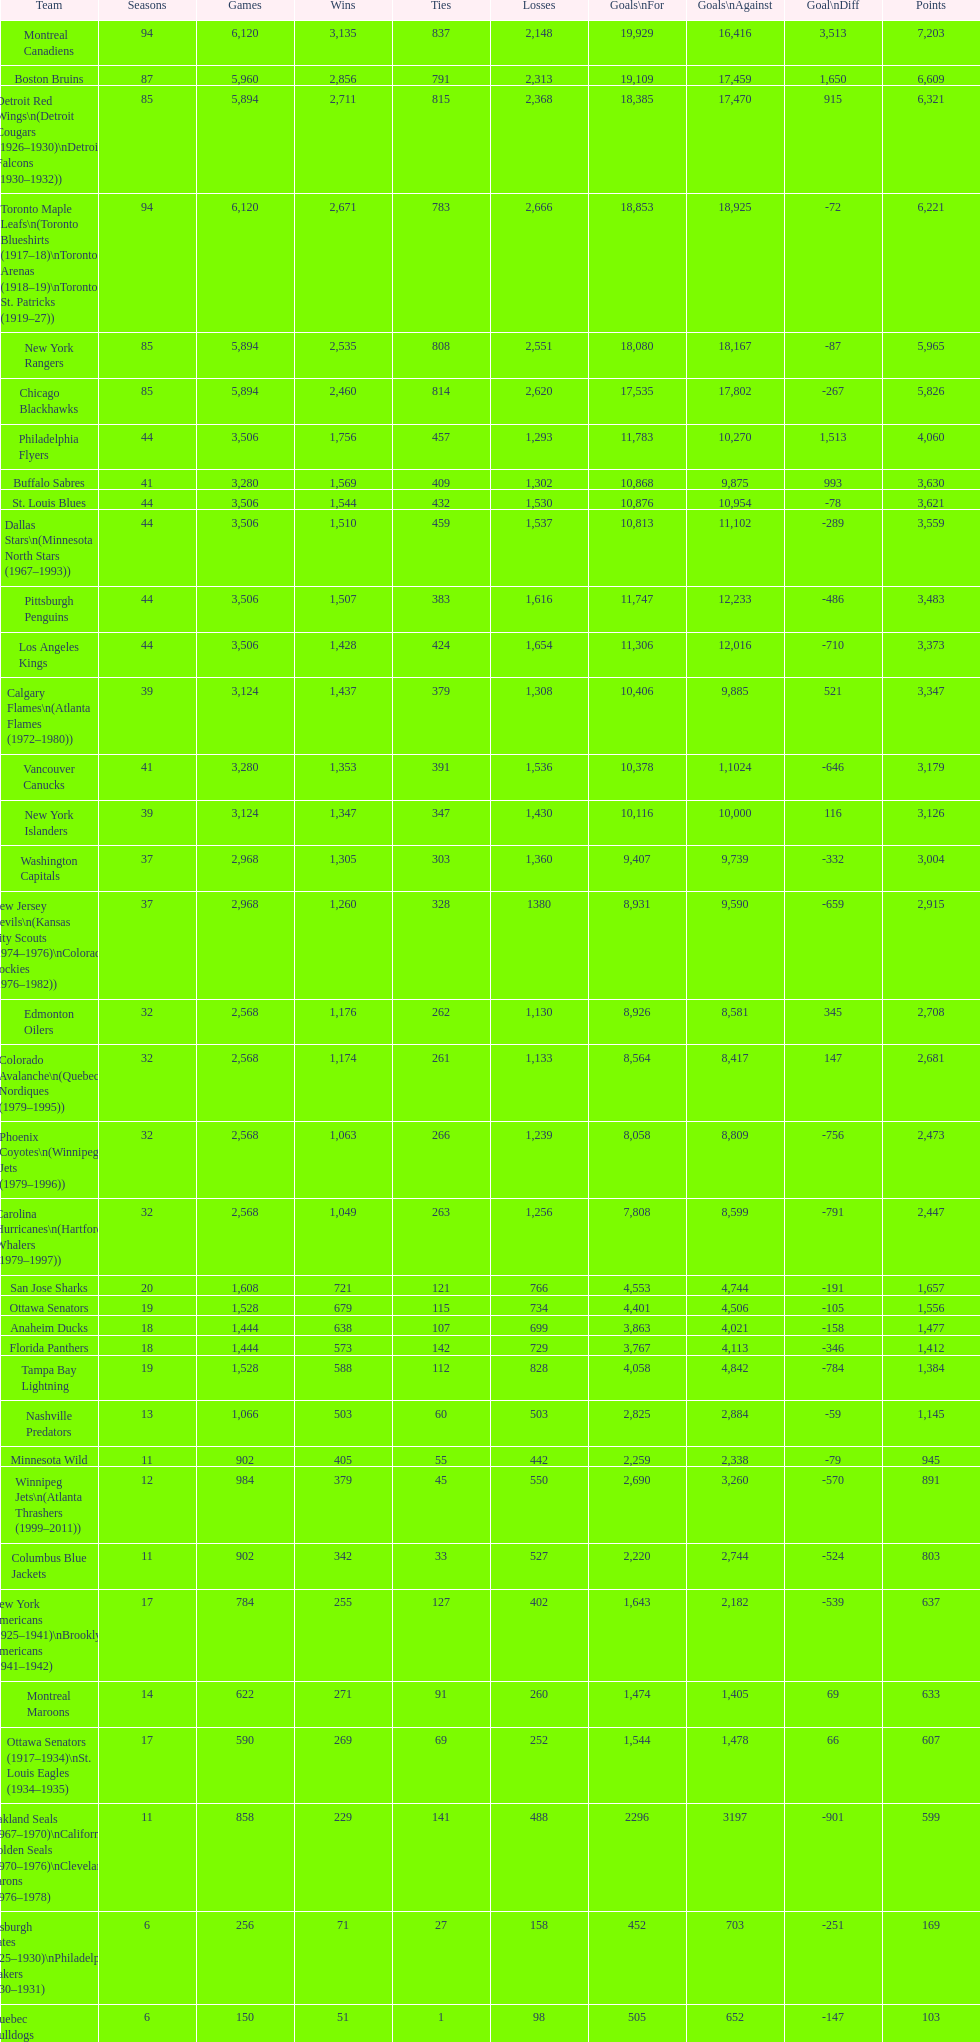Which team played the same amount of seasons as the canadiens? Toronto Maple Leafs. 